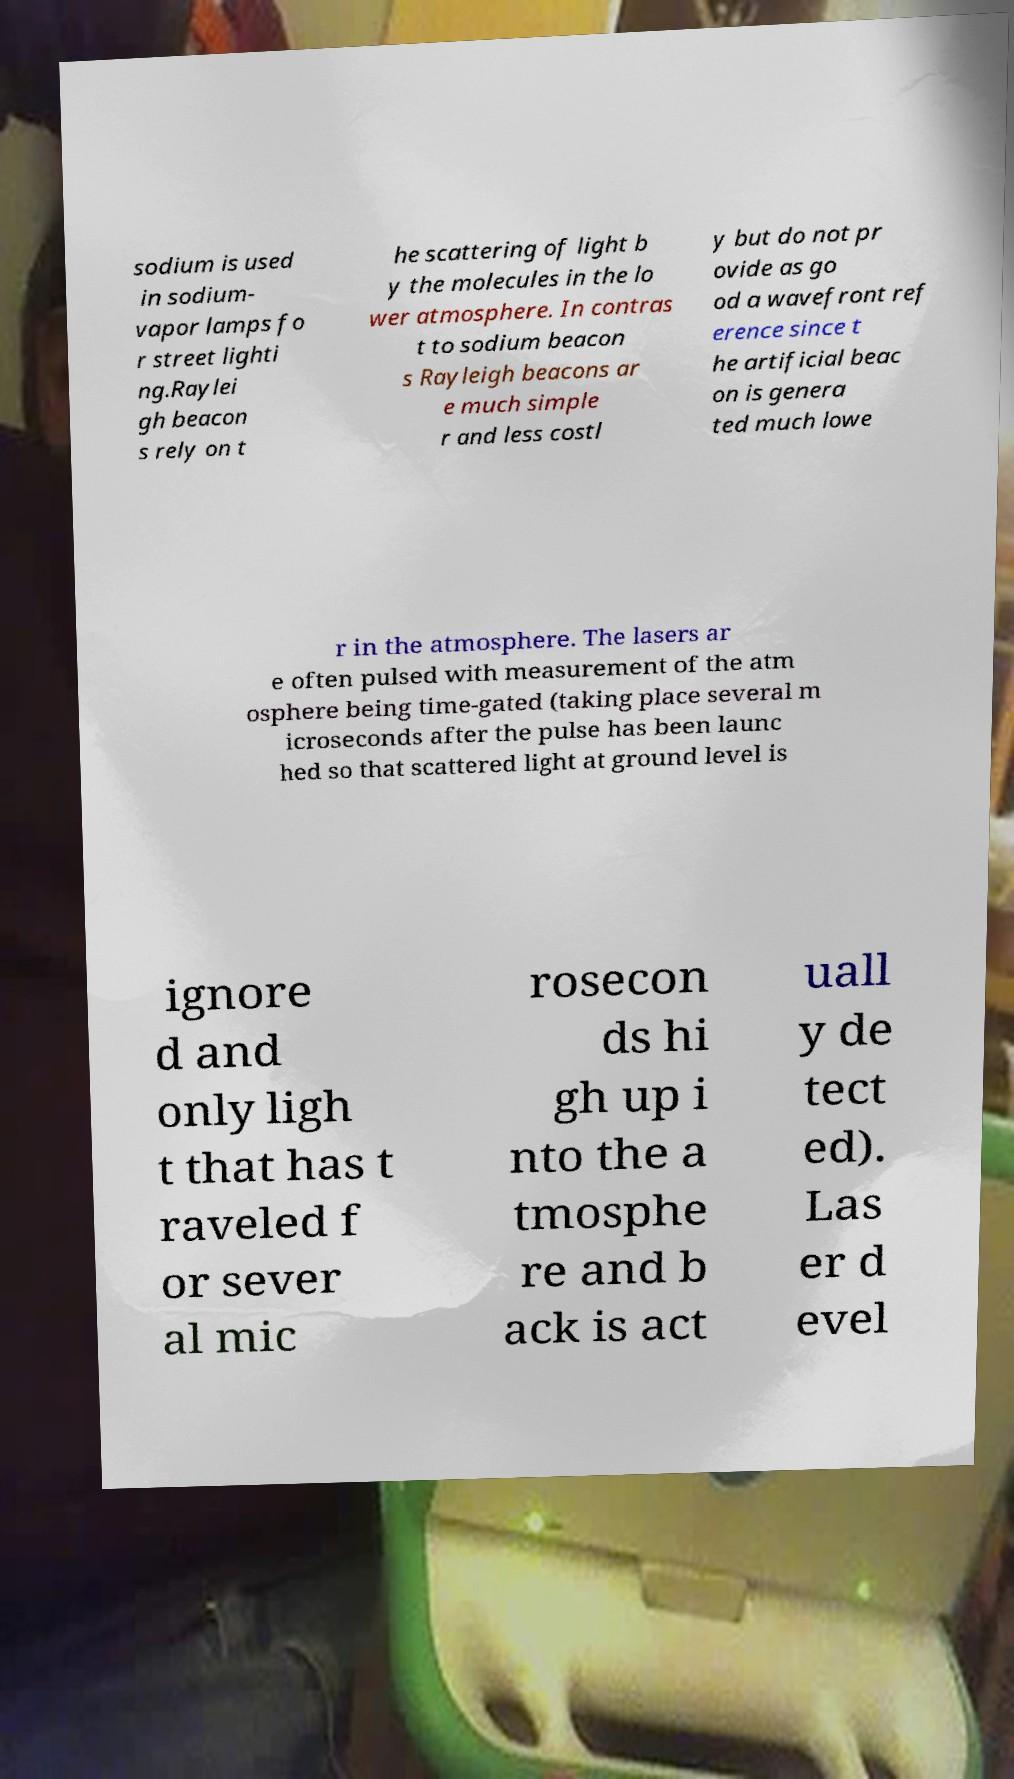Please read and relay the text visible in this image. What does it say? sodium is used in sodium- vapor lamps fo r street lighti ng.Raylei gh beacon s rely on t he scattering of light b y the molecules in the lo wer atmosphere. In contras t to sodium beacon s Rayleigh beacons ar e much simple r and less costl y but do not pr ovide as go od a wavefront ref erence since t he artificial beac on is genera ted much lowe r in the atmosphere. The lasers ar e often pulsed with measurement of the atm osphere being time-gated (taking place several m icroseconds after the pulse has been launc hed so that scattered light at ground level is ignore d and only ligh t that has t raveled f or sever al mic rosecon ds hi gh up i nto the a tmosphe re and b ack is act uall y de tect ed). Las er d evel 